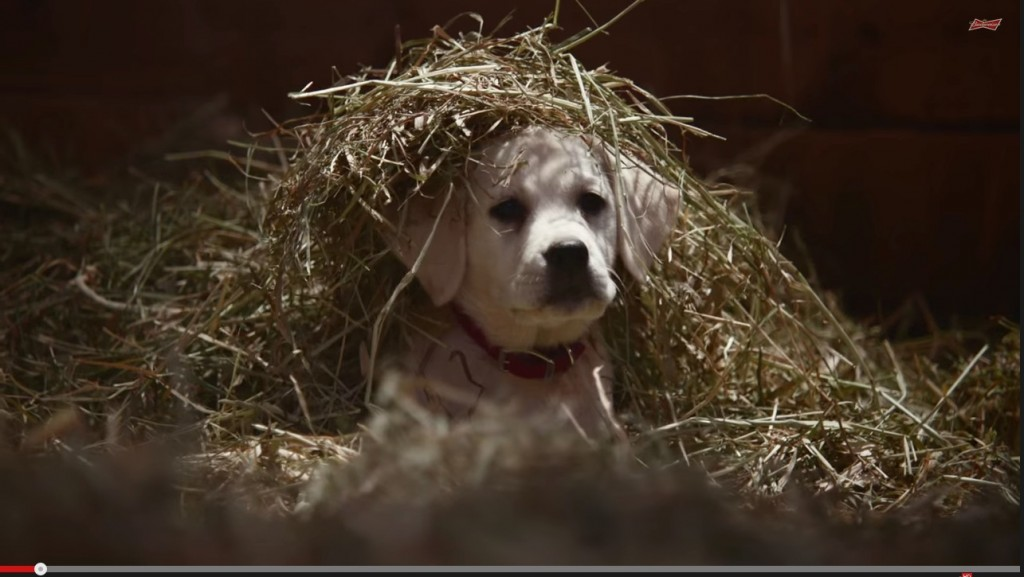Imagine a short film starring this puppy, what would be the main plot twist? The film would follow the puppy's journey as it navigates the barn, forming friendships with the other animals and bringing joy to everyone it meets. The main plot twist occurs when the puppy discovers an old, forgotten piece of farm equipment hidden under the hay. By pawing at it, the puppy inadvertently turns it on, revealing it to be a long-lost machine that produces delicious treats for all the barn animals. As the machine whirs to life, the animals witness a bounty of snacks spilling out, bringing excitement and celebration to the barn. The discovery cements the puppy’s status as a beloved and heroic figure among its barnyard friends. 
Based on the playful nature of the scene, write a short poem from the puppy’s perspective. In a barn so warm and snug,
I found a nest, on a playful lark,
With hay upon my head, so snug,
I felt like a king, tail a-wagging, hark!

The straw, like a crown of golden thread,
Rustling gently, a cozy bed,
In this barn I roamed and tread,
A world of wonder on my head.

With friends around me, laughter and cheer,
Every nook explored, everything dear,
Oh, what a joyful pup am I,
Under the barn's wide, open sky. 